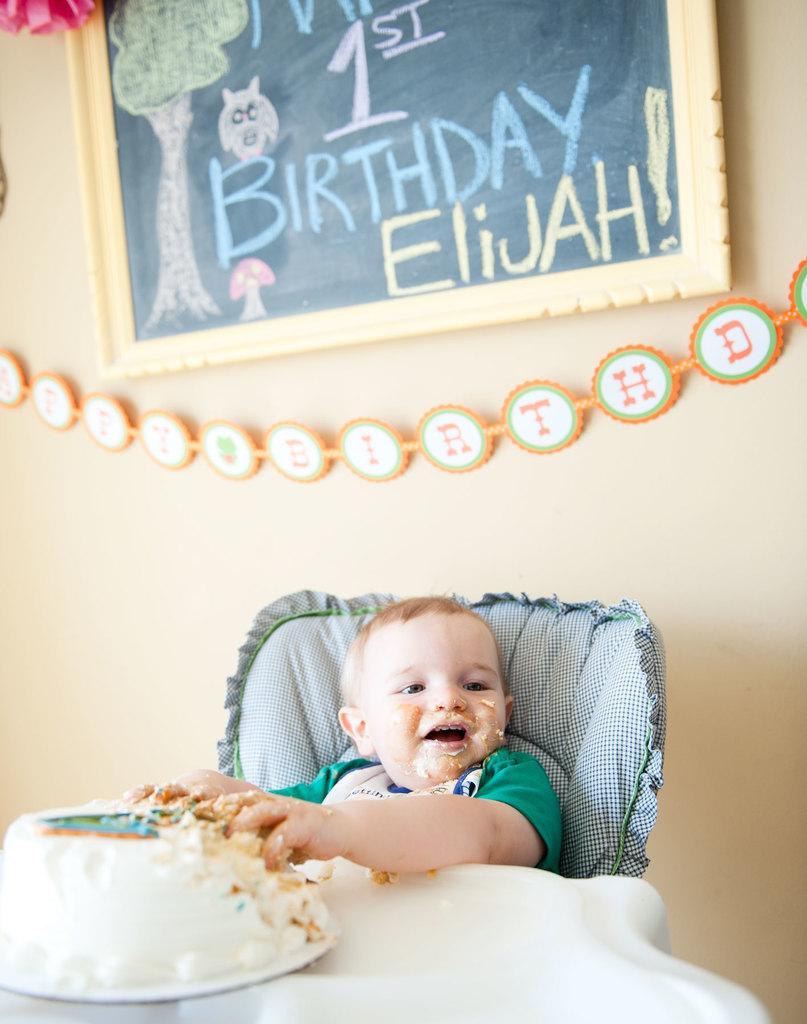In one or two sentences, can you explain what this image depicts? In this image I can see the person sitting. In front of the person I can see the cake and the cake is on the white color surface. In the background I can see the frame attached to the wall and the wall is in cream color. 